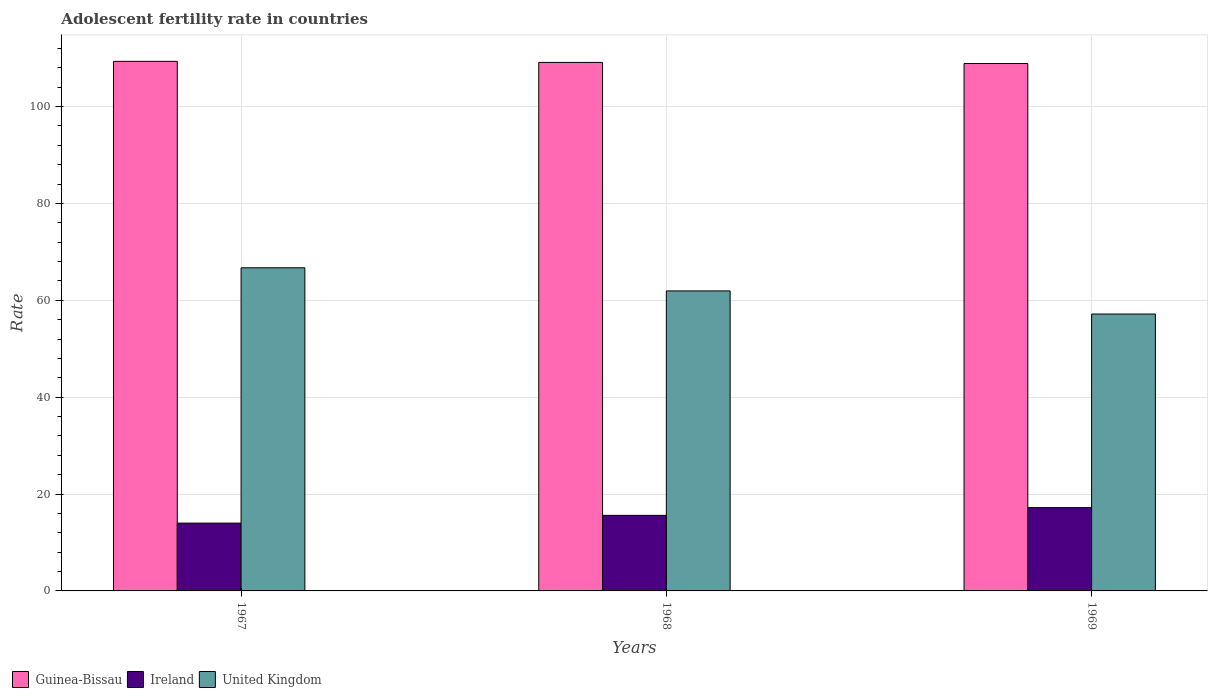How many groups of bars are there?
Your answer should be very brief. 3. Are the number of bars per tick equal to the number of legend labels?
Your answer should be compact. Yes. How many bars are there on the 2nd tick from the right?
Your answer should be compact. 3. What is the label of the 1st group of bars from the left?
Offer a very short reply. 1967. What is the adolescent fertility rate in United Kingdom in 1968?
Offer a terse response. 61.93. Across all years, what is the maximum adolescent fertility rate in United Kingdom?
Keep it short and to the point. 66.7. Across all years, what is the minimum adolescent fertility rate in Ireland?
Offer a terse response. 14. In which year was the adolescent fertility rate in Guinea-Bissau maximum?
Provide a succinct answer. 1967. In which year was the adolescent fertility rate in Ireland minimum?
Offer a very short reply. 1967. What is the total adolescent fertility rate in United Kingdom in the graph?
Ensure brevity in your answer.  185.79. What is the difference between the adolescent fertility rate in United Kingdom in 1968 and that in 1969?
Make the answer very short. 4.77. What is the difference between the adolescent fertility rate in Ireland in 1969 and the adolescent fertility rate in United Kingdom in 1967?
Your response must be concise. -49.5. What is the average adolescent fertility rate in United Kingdom per year?
Provide a succinct answer. 61.93. In the year 1968, what is the difference between the adolescent fertility rate in Ireland and adolescent fertility rate in United Kingdom?
Make the answer very short. -46.33. What is the ratio of the adolescent fertility rate in Ireland in 1967 to that in 1968?
Keep it short and to the point. 0.9. Is the adolescent fertility rate in United Kingdom in 1968 less than that in 1969?
Keep it short and to the point. No. Is the difference between the adolescent fertility rate in Ireland in 1967 and 1969 greater than the difference between the adolescent fertility rate in United Kingdom in 1967 and 1969?
Give a very brief answer. No. What is the difference between the highest and the second highest adolescent fertility rate in United Kingdom?
Your response must be concise. 4.77. What is the difference between the highest and the lowest adolescent fertility rate in Guinea-Bissau?
Ensure brevity in your answer.  0.45. In how many years, is the adolescent fertility rate in United Kingdom greater than the average adolescent fertility rate in United Kingdom taken over all years?
Ensure brevity in your answer.  1. Is the sum of the adolescent fertility rate in Ireland in 1967 and 1969 greater than the maximum adolescent fertility rate in Guinea-Bissau across all years?
Give a very brief answer. No. What does the 1st bar from the left in 1969 represents?
Offer a very short reply. Guinea-Bissau. What does the 1st bar from the right in 1967 represents?
Give a very brief answer. United Kingdom. How many bars are there?
Offer a terse response. 9. Are all the bars in the graph horizontal?
Your answer should be compact. No. How many years are there in the graph?
Provide a short and direct response. 3. What is the difference between two consecutive major ticks on the Y-axis?
Provide a short and direct response. 20. Does the graph contain any zero values?
Your answer should be compact. No. Does the graph contain grids?
Keep it short and to the point. Yes. How are the legend labels stacked?
Your answer should be very brief. Horizontal. What is the title of the graph?
Your response must be concise. Adolescent fertility rate in countries. Does "Slovak Republic" appear as one of the legend labels in the graph?
Your response must be concise. No. What is the label or title of the X-axis?
Make the answer very short. Years. What is the label or title of the Y-axis?
Provide a short and direct response. Rate. What is the Rate in Guinea-Bissau in 1967?
Your response must be concise. 109.32. What is the Rate in Ireland in 1967?
Give a very brief answer. 14. What is the Rate of United Kingdom in 1967?
Give a very brief answer. 66.7. What is the Rate of Guinea-Bissau in 1968?
Your response must be concise. 109.1. What is the Rate of Ireland in 1968?
Make the answer very short. 15.6. What is the Rate in United Kingdom in 1968?
Provide a succinct answer. 61.93. What is the Rate in Guinea-Bissau in 1969?
Offer a terse response. 108.87. What is the Rate of Ireland in 1969?
Keep it short and to the point. 17.2. What is the Rate in United Kingdom in 1969?
Your answer should be very brief. 57.16. Across all years, what is the maximum Rate in Guinea-Bissau?
Make the answer very short. 109.32. Across all years, what is the maximum Rate in Ireland?
Provide a succinct answer. 17.2. Across all years, what is the maximum Rate of United Kingdom?
Give a very brief answer. 66.7. Across all years, what is the minimum Rate in Guinea-Bissau?
Provide a succinct answer. 108.87. Across all years, what is the minimum Rate of Ireland?
Offer a terse response. 14. Across all years, what is the minimum Rate of United Kingdom?
Give a very brief answer. 57.16. What is the total Rate of Guinea-Bissau in the graph?
Ensure brevity in your answer.  327.29. What is the total Rate of Ireland in the graph?
Keep it short and to the point. 46.79. What is the total Rate of United Kingdom in the graph?
Your answer should be very brief. 185.79. What is the difference between the Rate of Guinea-Bissau in 1967 and that in 1968?
Make the answer very short. 0.22. What is the difference between the Rate of Ireland in 1967 and that in 1968?
Your response must be concise. -1.6. What is the difference between the Rate in United Kingdom in 1967 and that in 1968?
Give a very brief answer. 4.77. What is the difference between the Rate in Guinea-Bissau in 1967 and that in 1969?
Ensure brevity in your answer.  0.45. What is the difference between the Rate of Ireland in 1967 and that in 1969?
Make the answer very short. -3.2. What is the difference between the Rate in United Kingdom in 1967 and that in 1969?
Ensure brevity in your answer.  9.54. What is the difference between the Rate of Guinea-Bissau in 1968 and that in 1969?
Your answer should be compact. 0.22. What is the difference between the Rate in Ireland in 1968 and that in 1969?
Your answer should be compact. -1.6. What is the difference between the Rate of United Kingdom in 1968 and that in 1969?
Your answer should be compact. 4.77. What is the difference between the Rate of Guinea-Bissau in 1967 and the Rate of Ireland in 1968?
Your answer should be compact. 93.72. What is the difference between the Rate in Guinea-Bissau in 1967 and the Rate in United Kingdom in 1968?
Provide a short and direct response. 47.39. What is the difference between the Rate of Ireland in 1967 and the Rate of United Kingdom in 1968?
Offer a very short reply. -47.93. What is the difference between the Rate in Guinea-Bissau in 1967 and the Rate in Ireland in 1969?
Your answer should be compact. 92.12. What is the difference between the Rate in Guinea-Bissau in 1967 and the Rate in United Kingdom in 1969?
Your response must be concise. 52.16. What is the difference between the Rate of Ireland in 1967 and the Rate of United Kingdom in 1969?
Provide a succinct answer. -43.16. What is the difference between the Rate of Guinea-Bissau in 1968 and the Rate of Ireland in 1969?
Offer a terse response. 91.9. What is the difference between the Rate in Guinea-Bissau in 1968 and the Rate in United Kingdom in 1969?
Your answer should be very brief. 51.94. What is the difference between the Rate in Ireland in 1968 and the Rate in United Kingdom in 1969?
Offer a terse response. -41.56. What is the average Rate in Guinea-Bissau per year?
Provide a short and direct response. 109.1. What is the average Rate in Ireland per year?
Give a very brief answer. 15.6. What is the average Rate of United Kingdom per year?
Give a very brief answer. 61.93. In the year 1967, what is the difference between the Rate in Guinea-Bissau and Rate in Ireland?
Provide a succinct answer. 95.32. In the year 1967, what is the difference between the Rate of Guinea-Bissau and Rate of United Kingdom?
Your response must be concise. 42.62. In the year 1967, what is the difference between the Rate of Ireland and Rate of United Kingdom?
Offer a very short reply. -52.7. In the year 1968, what is the difference between the Rate in Guinea-Bissau and Rate in Ireland?
Your answer should be very brief. 93.5. In the year 1968, what is the difference between the Rate of Guinea-Bissau and Rate of United Kingdom?
Make the answer very short. 47.16. In the year 1968, what is the difference between the Rate in Ireland and Rate in United Kingdom?
Keep it short and to the point. -46.33. In the year 1969, what is the difference between the Rate in Guinea-Bissau and Rate in Ireland?
Provide a short and direct response. 91.68. In the year 1969, what is the difference between the Rate of Guinea-Bissau and Rate of United Kingdom?
Offer a very short reply. 51.71. In the year 1969, what is the difference between the Rate of Ireland and Rate of United Kingdom?
Ensure brevity in your answer.  -39.96. What is the ratio of the Rate of Ireland in 1967 to that in 1968?
Your answer should be compact. 0.9. What is the ratio of the Rate of United Kingdom in 1967 to that in 1968?
Ensure brevity in your answer.  1.08. What is the ratio of the Rate of Ireland in 1967 to that in 1969?
Provide a short and direct response. 0.81. What is the ratio of the Rate of United Kingdom in 1967 to that in 1969?
Ensure brevity in your answer.  1.17. What is the ratio of the Rate in Guinea-Bissau in 1968 to that in 1969?
Give a very brief answer. 1. What is the ratio of the Rate of Ireland in 1968 to that in 1969?
Provide a short and direct response. 0.91. What is the ratio of the Rate in United Kingdom in 1968 to that in 1969?
Offer a terse response. 1.08. What is the difference between the highest and the second highest Rate in Guinea-Bissau?
Keep it short and to the point. 0.22. What is the difference between the highest and the second highest Rate in Ireland?
Ensure brevity in your answer.  1.6. What is the difference between the highest and the second highest Rate in United Kingdom?
Offer a very short reply. 4.77. What is the difference between the highest and the lowest Rate of Guinea-Bissau?
Give a very brief answer. 0.45. What is the difference between the highest and the lowest Rate of Ireland?
Give a very brief answer. 3.2. What is the difference between the highest and the lowest Rate in United Kingdom?
Provide a short and direct response. 9.54. 